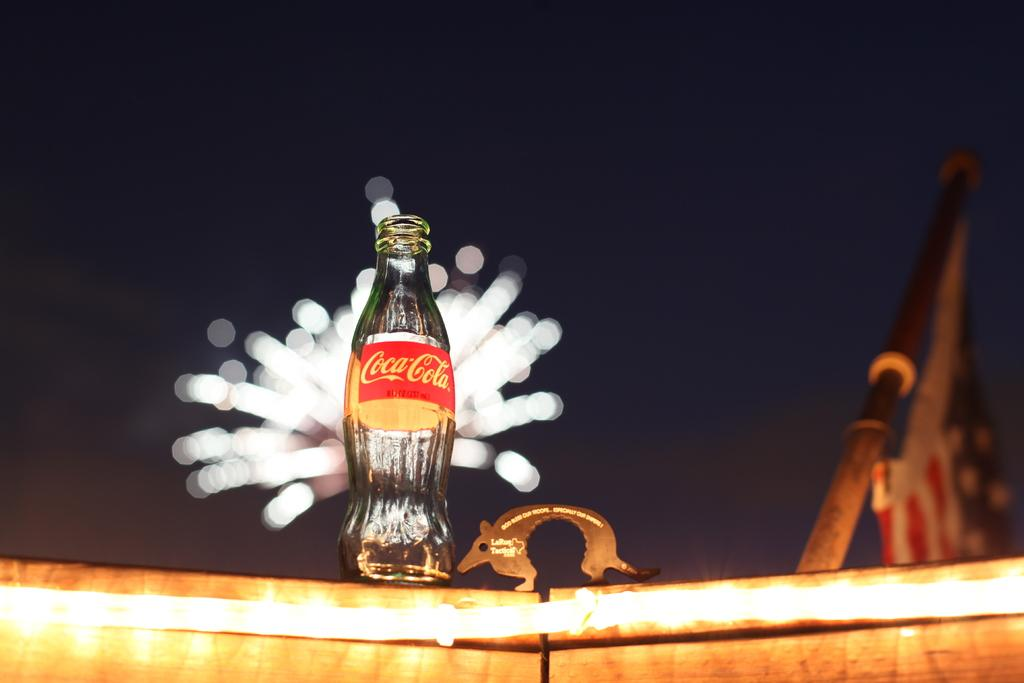<image>
Share a concise interpretation of the image provided. A bottle of Coca Cola sits on a boat railing in front of fireworks 